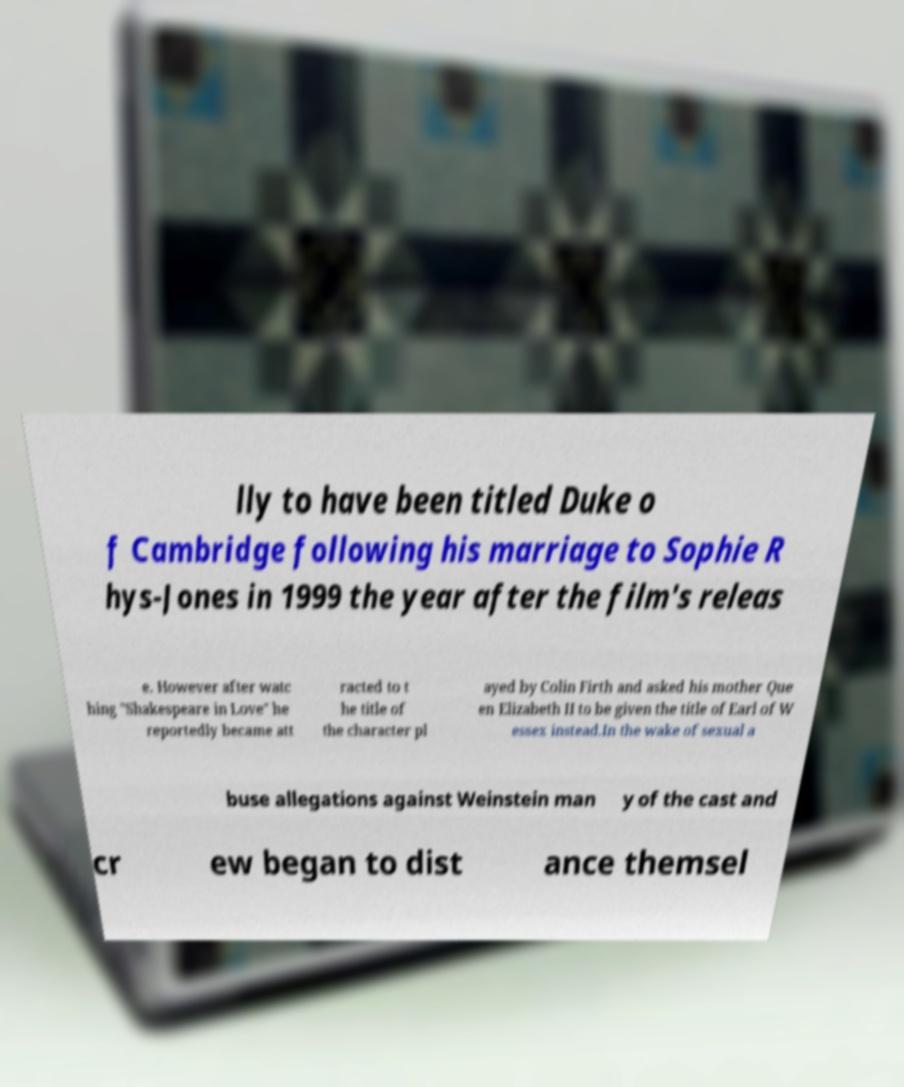I need the written content from this picture converted into text. Can you do that? lly to have been titled Duke o f Cambridge following his marriage to Sophie R hys-Jones in 1999 the year after the film's releas e. However after watc hing "Shakespeare in Love" he reportedly became att racted to t he title of the character pl ayed by Colin Firth and asked his mother Que en Elizabeth II to be given the title of Earl of W essex instead.In the wake of sexual a buse allegations against Weinstein man y of the cast and cr ew began to dist ance themsel 